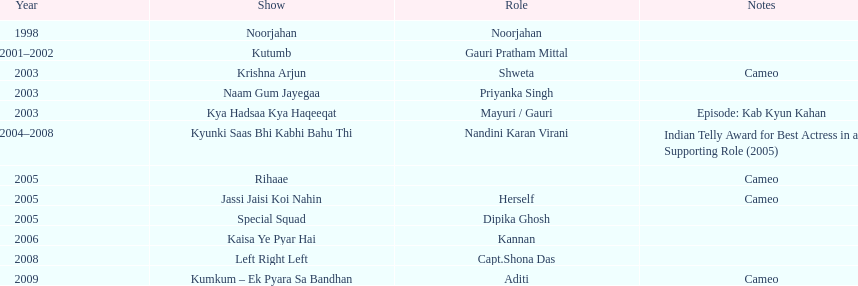What was the most years a show lasted? 4. 